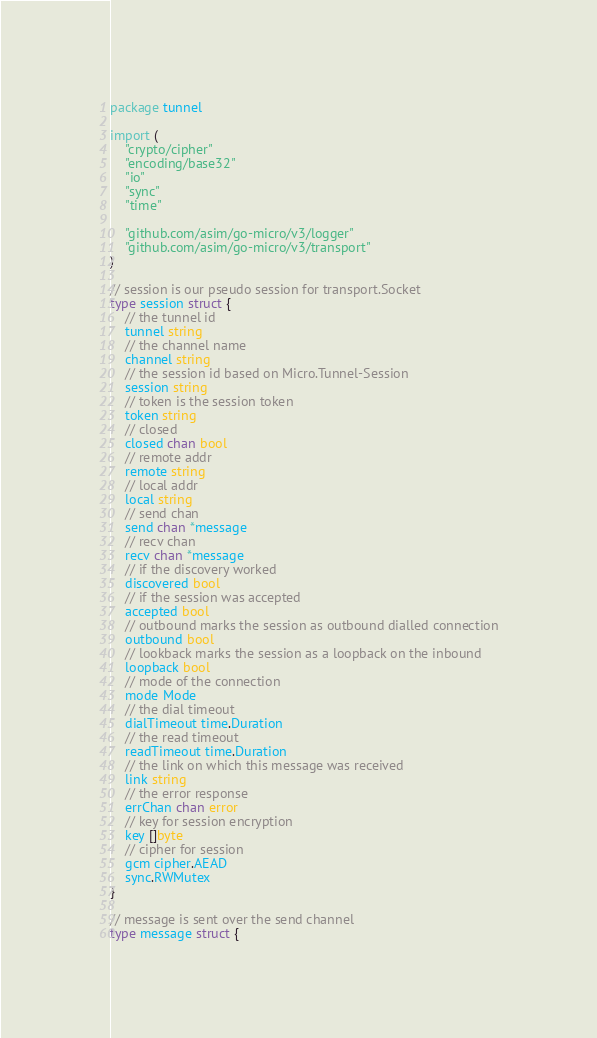Convert code to text. <code><loc_0><loc_0><loc_500><loc_500><_Go_>package tunnel

import (
	"crypto/cipher"
	"encoding/base32"
	"io"
	"sync"
	"time"

	"github.com/asim/go-micro/v3/logger"
	"github.com/asim/go-micro/v3/transport"
)

// session is our pseudo session for transport.Socket
type session struct {
	// the tunnel id
	tunnel string
	// the channel name
	channel string
	// the session id based on Micro.Tunnel-Session
	session string
	// token is the session token
	token string
	// closed
	closed chan bool
	// remote addr
	remote string
	// local addr
	local string
	// send chan
	send chan *message
	// recv chan
	recv chan *message
	// if the discovery worked
	discovered bool
	// if the session was accepted
	accepted bool
	// outbound marks the session as outbound dialled connection
	outbound bool
	// lookback marks the session as a loopback on the inbound
	loopback bool
	// mode of the connection
	mode Mode
	// the dial timeout
	dialTimeout time.Duration
	// the read timeout
	readTimeout time.Duration
	// the link on which this message was received
	link string
	// the error response
	errChan chan error
	// key for session encryption
	key []byte
	// cipher for session
	gcm cipher.AEAD
	sync.RWMutex
}

// message is sent over the send channel
type message struct {</code> 